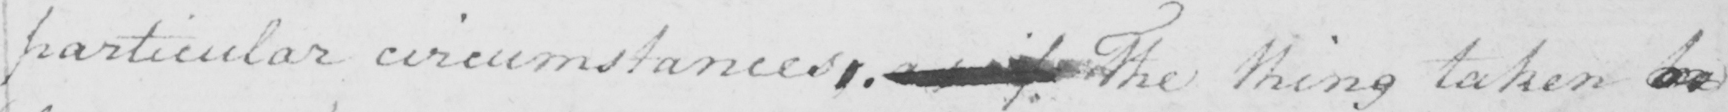Transcribe the text shown in this historical manuscript line. particular circumstances .   <gap/>   The thing taken   <gap/> 